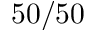Convert formula to latex. <formula><loc_0><loc_0><loc_500><loc_500>5 0 / 5 0</formula> 